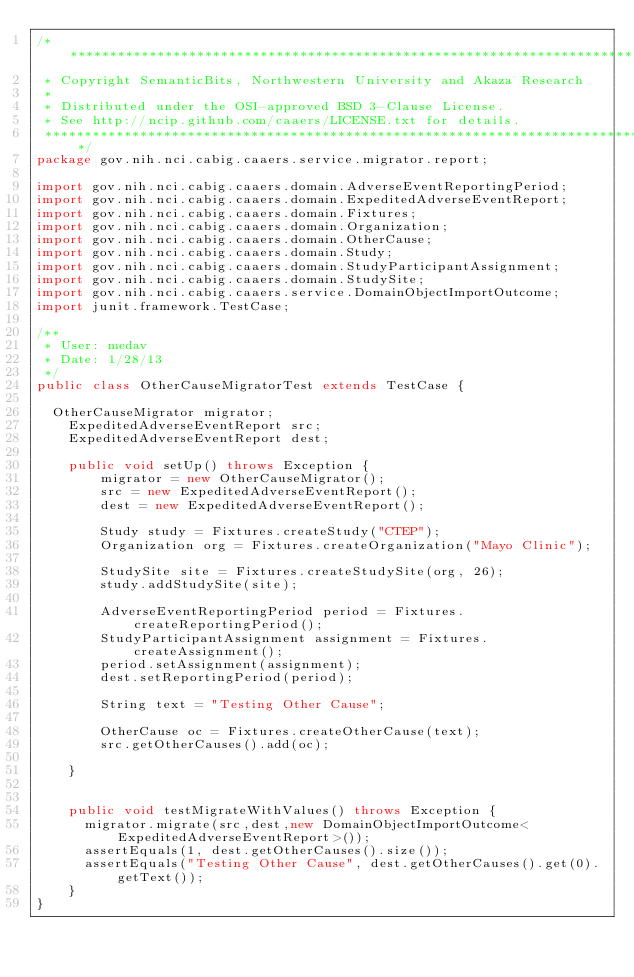<code> <loc_0><loc_0><loc_500><loc_500><_Java_>/*******************************************************************************
 * Copyright SemanticBits, Northwestern University and Akaza Research
 * 
 * Distributed under the OSI-approved BSD 3-Clause License.
 * See http://ncip.github.com/caaers/LICENSE.txt for details.
 ******************************************************************************/
package gov.nih.nci.cabig.caaers.service.migrator.report;

import gov.nih.nci.cabig.caaers.domain.AdverseEventReportingPeriod;
import gov.nih.nci.cabig.caaers.domain.ExpeditedAdverseEventReport;
import gov.nih.nci.cabig.caaers.domain.Fixtures;
import gov.nih.nci.cabig.caaers.domain.Organization;
import gov.nih.nci.cabig.caaers.domain.OtherCause;
import gov.nih.nci.cabig.caaers.domain.Study;
import gov.nih.nci.cabig.caaers.domain.StudyParticipantAssignment;
import gov.nih.nci.cabig.caaers.domain.StudySite;
import gov.nih.nci.cabig.caaers.service.DomainObjectImportOutcome;
import junit.framework.TestCase;

/**
 * User: medav
 * Date: 1/28/13
 */
public class OtherCauseMigratorTest extends TestCase {

	OtherCauseMigrator migrator;
    ExpeditedAdverseEventReport src;
    ExpeditedAdverseEventReport dest;

    public void setUp() throws Exception {
        migrator = new OtherCauseMigrator();
        src = new ExpeditedAdverseEventReport();
        dest = new ExpeditedAdverseEventReport();
        
        Study study = Fixtures.createStudy("CTEP");
        Organization org = Fixtures.createOrganization("Mayo Clinic");
        
        StudySite site = Fixtures.createStudySite(org, 26);
        study.addStudySite(site);
        
        AdverseEventReportingPeriod period = Fixtures.createReportingPeriod();
        StudyParticipantAssignment assignment = Fixtures.createAssignment();
        period.setAssignment(assignment);
        dest.setReportingPeriod(period);
        
        String text = "Testing Other Cause";
        
        OtherCause oc = Fixtures.createOtherCause(text);
        src.getOtherCauses().add(oc);
               
    }


    public void testMigrateWithValues() throws Exception {
    	migrator.migrate(src,dest,new DomainObjectImportOutcome<ExpeditedAdverseEventReport>());
    	assertEquals(1, dest.getOtherCauses().size());
    	assertEquals("Testing Other Cause", dest.getOtherCauses().get(0).getText());
    }
}
</code> 